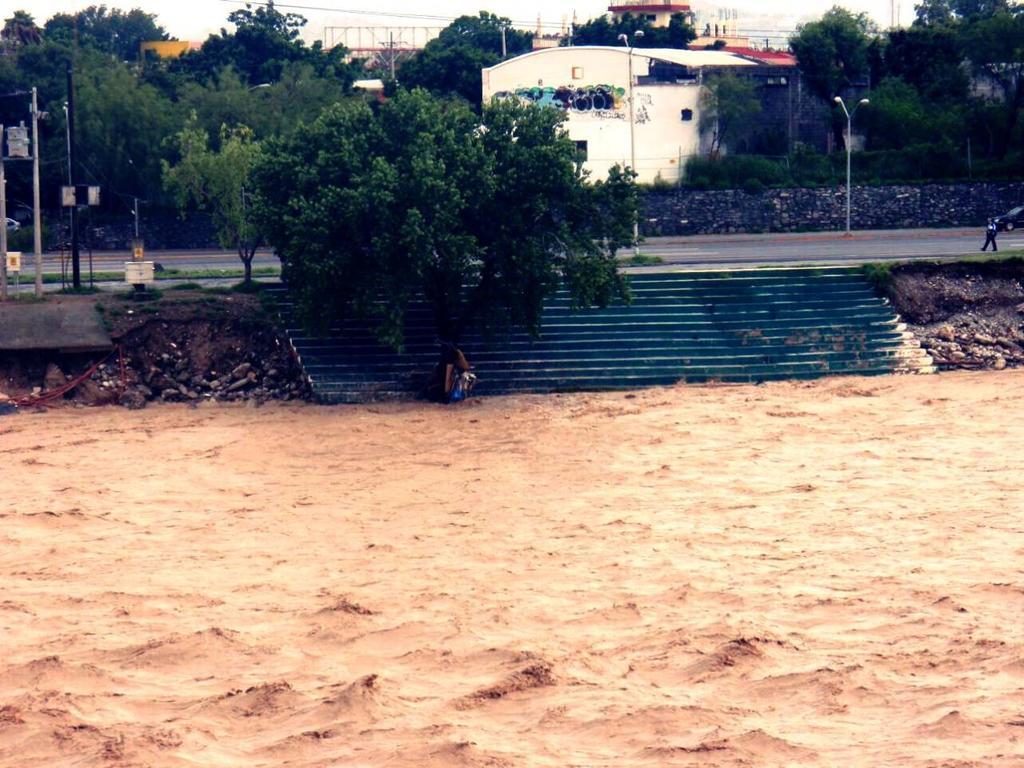Can you describe this image briefly? In this mage in the front there is sand on the ground. In the center there are steps and there is a person sitting, there are trees. In the background there are poles and there is a person walking, there are buildings, trees and there are wires and there is a road. 